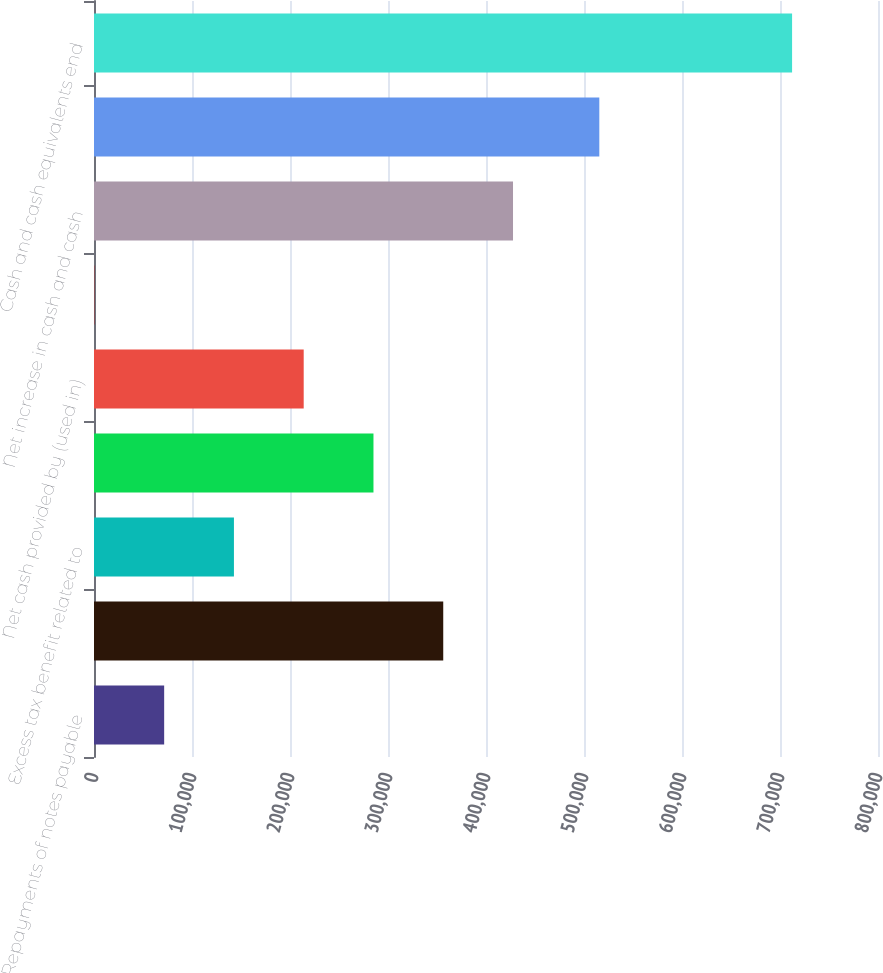<chart> <loc_0><loc_0><loc_500><loc_500><bar_chart><fcel>Repayments of notes payable<fcel>Net proceeds from issuance of<fcel>Excess tax benefit related to<fcel>Payments of employee<fcel>Net cash provided by (used in)<fcel>Effect of exchange rate<fcel>Net increase in cash and cash<fcel>Cash and cash equivalents<fcel>Cash and cash equivalents end<nl><fcel>71596.8<fcel>356368<fcel>142790<fcel>285175<fcel>213982<fcel>404<fcel>427561<fcel>515625<fcel>712332<nl></chart> 